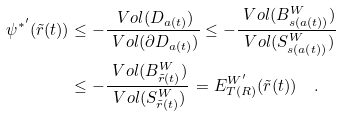<formula> <loc_0><loc_0><loc_500><loc_500>\psi ^ { * ^ { \prime } } ( \tilde { r } ( t ) ) & \leq - \frac { \ V o l ( D _ { a ( t ) } ) } { \ V o l ( \partial D _ { a ( t ) } ) } \leq - \frac { \ V o l ( B ^ { W } _ { s ( a ( t ) ) } ) } { \ V o l ( S ^ { W } _ { s ( a ( t ) ) } ) } \\ & \leq - \frac { \ V o l ( B ^ { W } _ { \tilde { r } ( t ) } ) } { \ V o l ( S ^ { W } _ { \tilde { r } ( t ) } ) } \, = E ^ { W ^ { \prime } } _ { T ( R ) } ( \tilde { r } ( t ) ) \quad .</formula> 